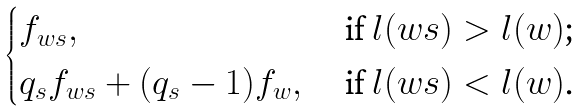Convert formula to latex. <formula><loc_0><loc_0><loc_500><loc_500>\begin{cases} f _ { w s } , & \text { if $l(ws)>l(w)$;} \\ q _ { s } f _ { w s } + ( q _ { s } - 1 ) f _ { w } , & \text { if $l(ws)<l(w)$.} \end{cases}</formula> 